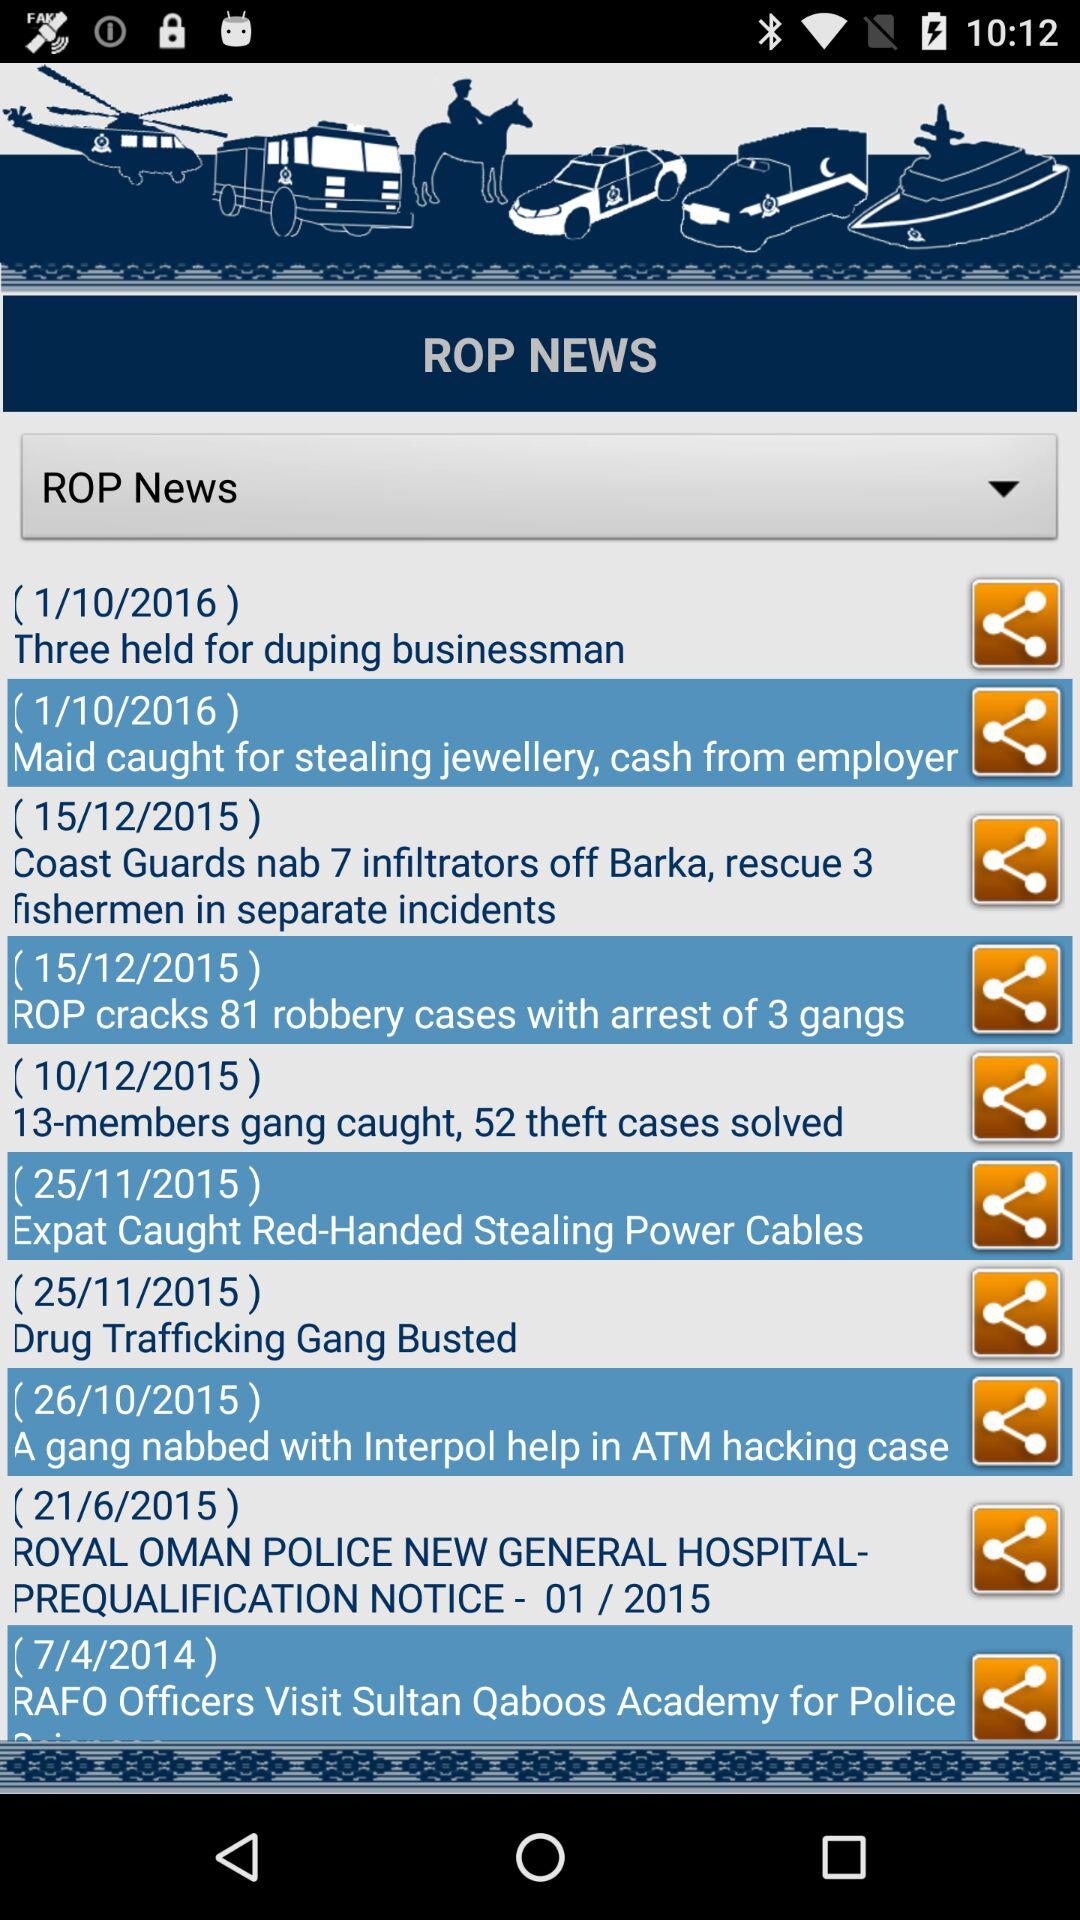When was the news "Drug Trafficking Gang Busted" posted? The news "Drug Trafficking Gang Busted" was posted on November 25, 2015. 